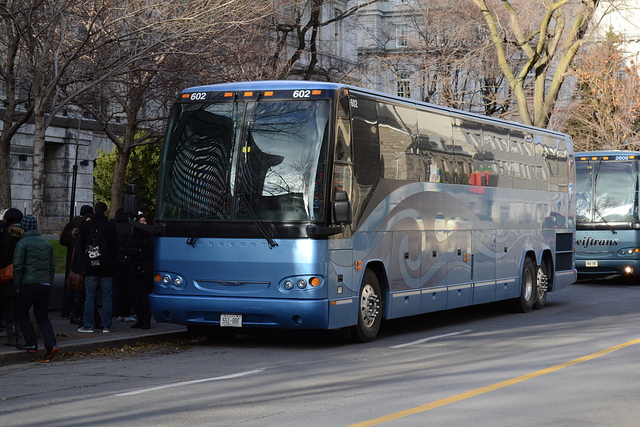Please transcribe the text in this image. 602 